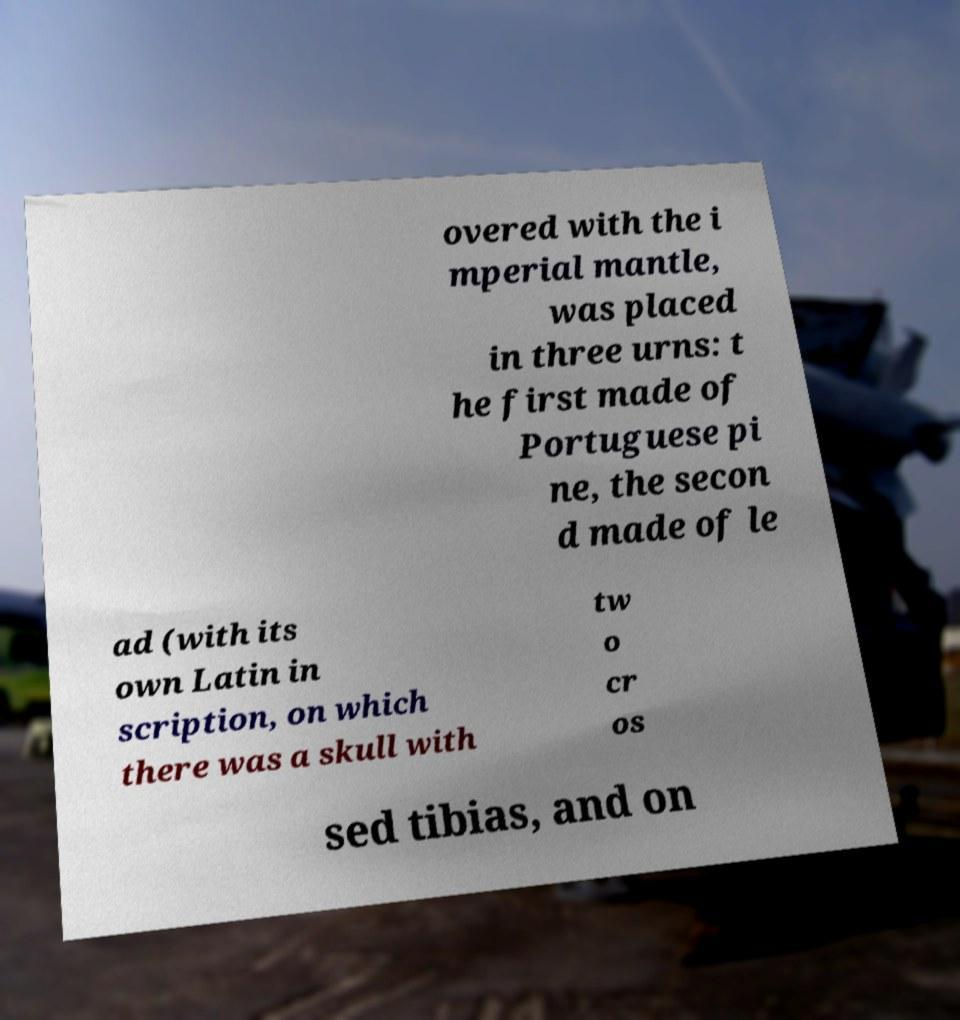Could you assist in decoding the text presented in this image and type it out clearly? overed with the i mperial mantle, was placed in three urns: t he first made of Portuguese pi ne, the secon d made of le ad (with its own Latin in scription, on which there was a skull with tw o cr os sed tibias, and on 